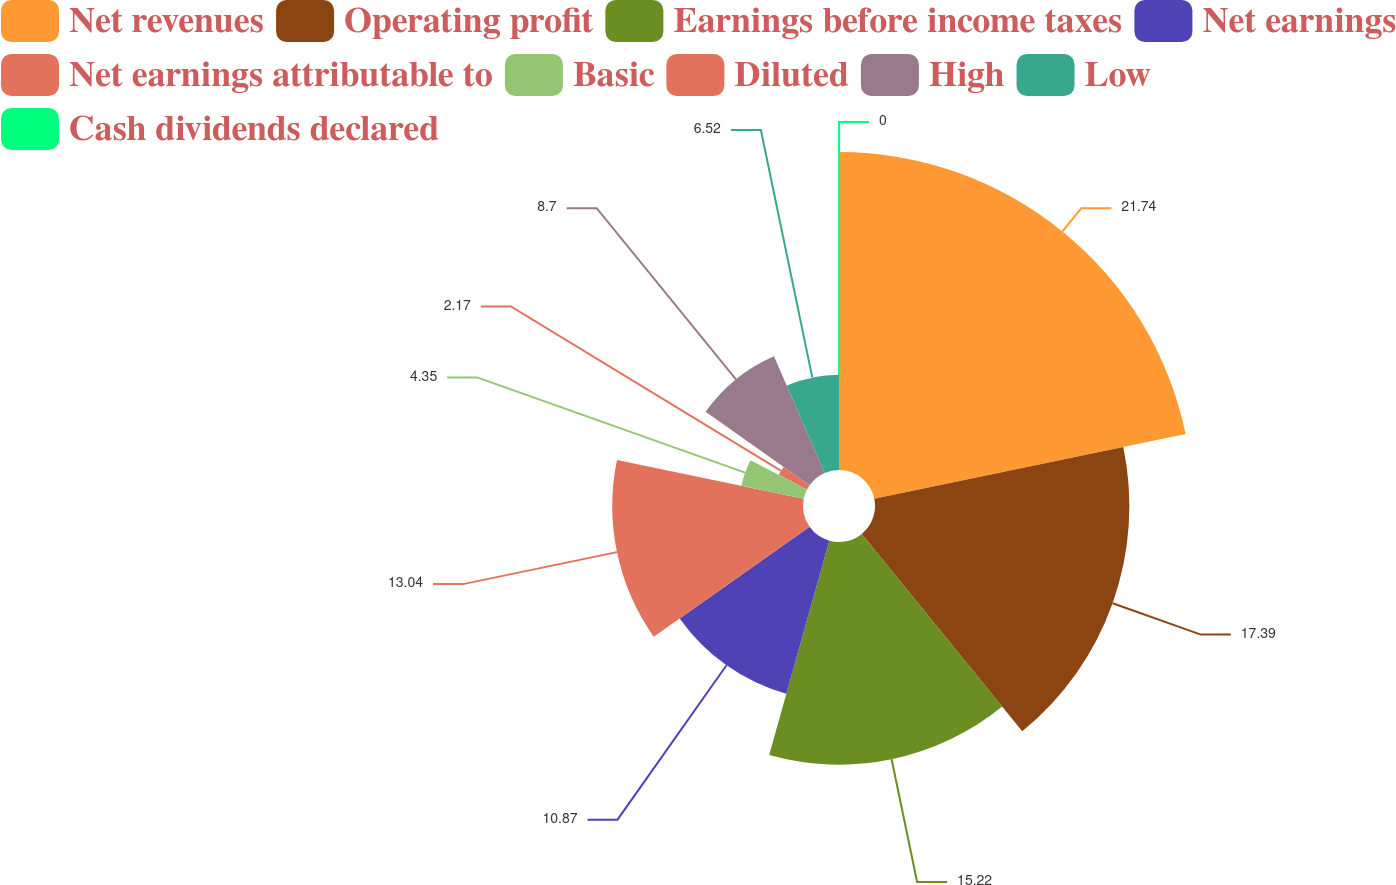<chart> <loc_0><loc_0><loc_500><loc_500><pie_chart><fcel>Net revenues<fcel>Operating profit<fcel>Earnings before income taxes<fcel>Net earnings<fcel>Net earnings attributable to<fcel>Basic<fcel>Diluted<fcel>High<fcel>Low<fcel>Cash dividends declared<nl><fcel>21.74%<fcel>17.39%<fcel>15.22%<fcel>10.87%<fcel>13.04%<fcel>4.35%<fcel>2.17%<fcel>8.7%<fcel>6.52%<fcel>0.0%<nl></chart> 